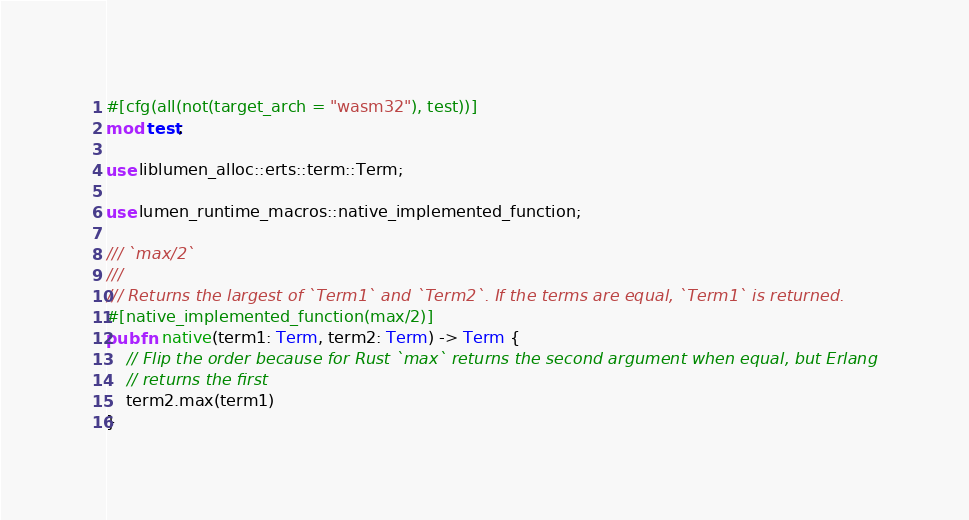Convert code to text. <code><loc_0><loc_0><loc_500><loc_500><_Rust_>#[cfg(all(not(target_arch = "wasm32"), test))]
mod test;

use liblumen_alloc::erts::term::Term;

use lumen_runtime_macros::native_implemented_function;

/// `max/2`
///
/// Returns the largest of `Term1` and `Term2`. If the terms are equal, `Term1` is returned.
#[native_implemented_function(max/2)]
pub fn native(term1: Term, term2: Term) -> Term {
    // Flip the order because for Rust `max` returns the second argument when equal, but Erlang
    // returns the first
    term2.max(term1)
}
</code> 